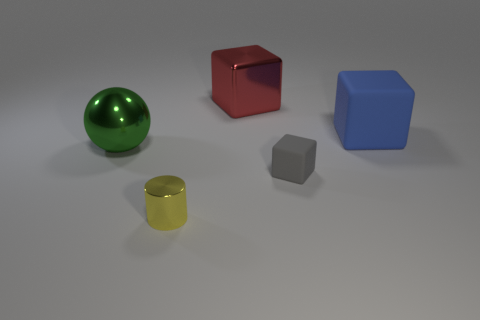Add 1 tiny gray matte cylinders. How many objects exist? 6 Subtract all cylinders. How many objects are left? 4 Add 4 tiny objects. How many tiny objects are left? 6 Add 2 red cubes. How many red cubes exist? 3 Subtract 1 red cubes. How many objects are left? 4 Subtract all yellow matte things. Subtract all red things. How many objects are left? 4 